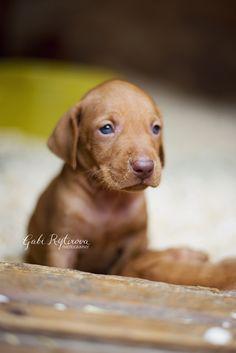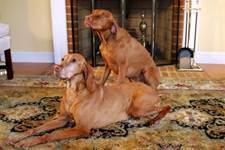The first image is the image on the left, the second image is the image on the right. For the images shown, is this caption "A dog is laying down inside." true? Answer yes or no. Yes. The first image is the image on the left, the second image is the image on the right. For the images displayed, is the sentence "The left image features a puppy peering over a wooden ledge, and the right image includes a reclining adult dog with its head lifted to gaze upward." factually correct? Answer yes or no. Yes. 